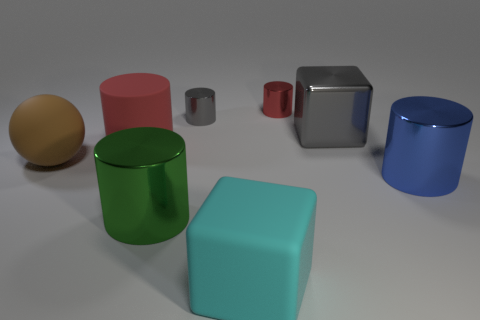There is another big object that is the same shape as the big cyan thing; what color is it?
Offer a very short reply. Gray. What number of big metallic blocks have the same color as the matte block?
Make the answer very short. 0. The red metallic thing has what size?
Offer a very short reply. Small. Does the gray cube have the same size as the red metal object?
Make the answer very short. No. What color is the object that is to the right of the big cyan cube and in front of the big metal block?
Your response must be concise. Blue. How many small red cylinders have the same material as the blue cylinder?
Provide a short and direct response. 1. What number of brown objects are there?
Offer a very short reply. 1. There is a red matte cylinder; is it the same size as the red cylinder on the right side of the big red thing?
Your answer should be very brief. No. There is a red cylinder left of the matte object that is right of the big red matte cylinder; what is it made of?
Your answer should be very brief. Rubber. There is a red thing that is right of the big metallic thing that is on the left side of the tiny cylinder in front of the tiny red metallic thing; how big is it?
Provide a succinct answer. Small. 